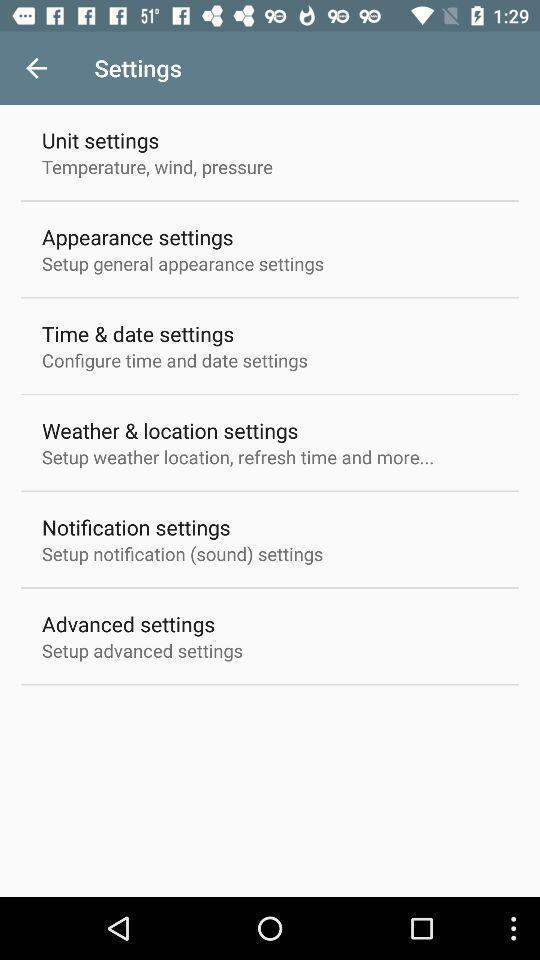Tell me about the visual elements in this screen capture. Screen showing settings page. 